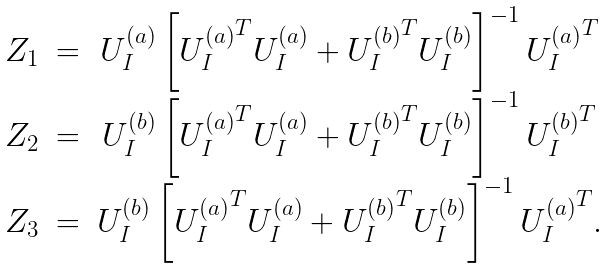Convert formula to latex. <formula><loc_0><loc_0><loc_500><loc_500>\begin{array} { c c c } { Z } _ { 1 } & = & { U } _ { I } ^ { ( a ) } \left [ { { U } _ { I } ^ { ( a ) } } ^ { T } { U } _ { I } ^ { ( a ) } + { { U } _ { I } ^ { ( b ) } } ^ { T } { U } _ { I } ^ { ( b ) } \right ] ^ { - 1 } { { U } _ { I } ^ { ( a ) } } ^ { T } \\ { Z } _ { 2 } & = & { U } _ { I } ^ { ( b ) } \left [ { { U } _ { I } ^ { ( a ) } } ^ { T } { U } _ { I } ^ { ( a ) } + { { U } _ { I } ^ { ( b ) } } ^ { T } { U } _ { I } ^ { ( b ) } \right ] ^ { - 1 } { { U } _ { I } ^ { ( b ) } } ^ { T } \\ { Z } _ { 3 } & = & { U } _ { I } ^ { ( b ) } \left [ { { U } _ { I } ^ { ( a ) } } ^ { T } { U } _ { I } ^ { ( a ) } + { { U } _ { I } ^ { ( b ) } } ^ { T } { U } _ { I } ^ { ( b ) } \right ] ^ { - 1 } { { U } _ { I } ^ { ( a ) } } ^ { T } . \\ \end{array}</formula> 